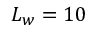Convert formula to latex. <formula><loc_0><loc_0><loc_500><loc_500>L _ { w } = 1 0</formula> 